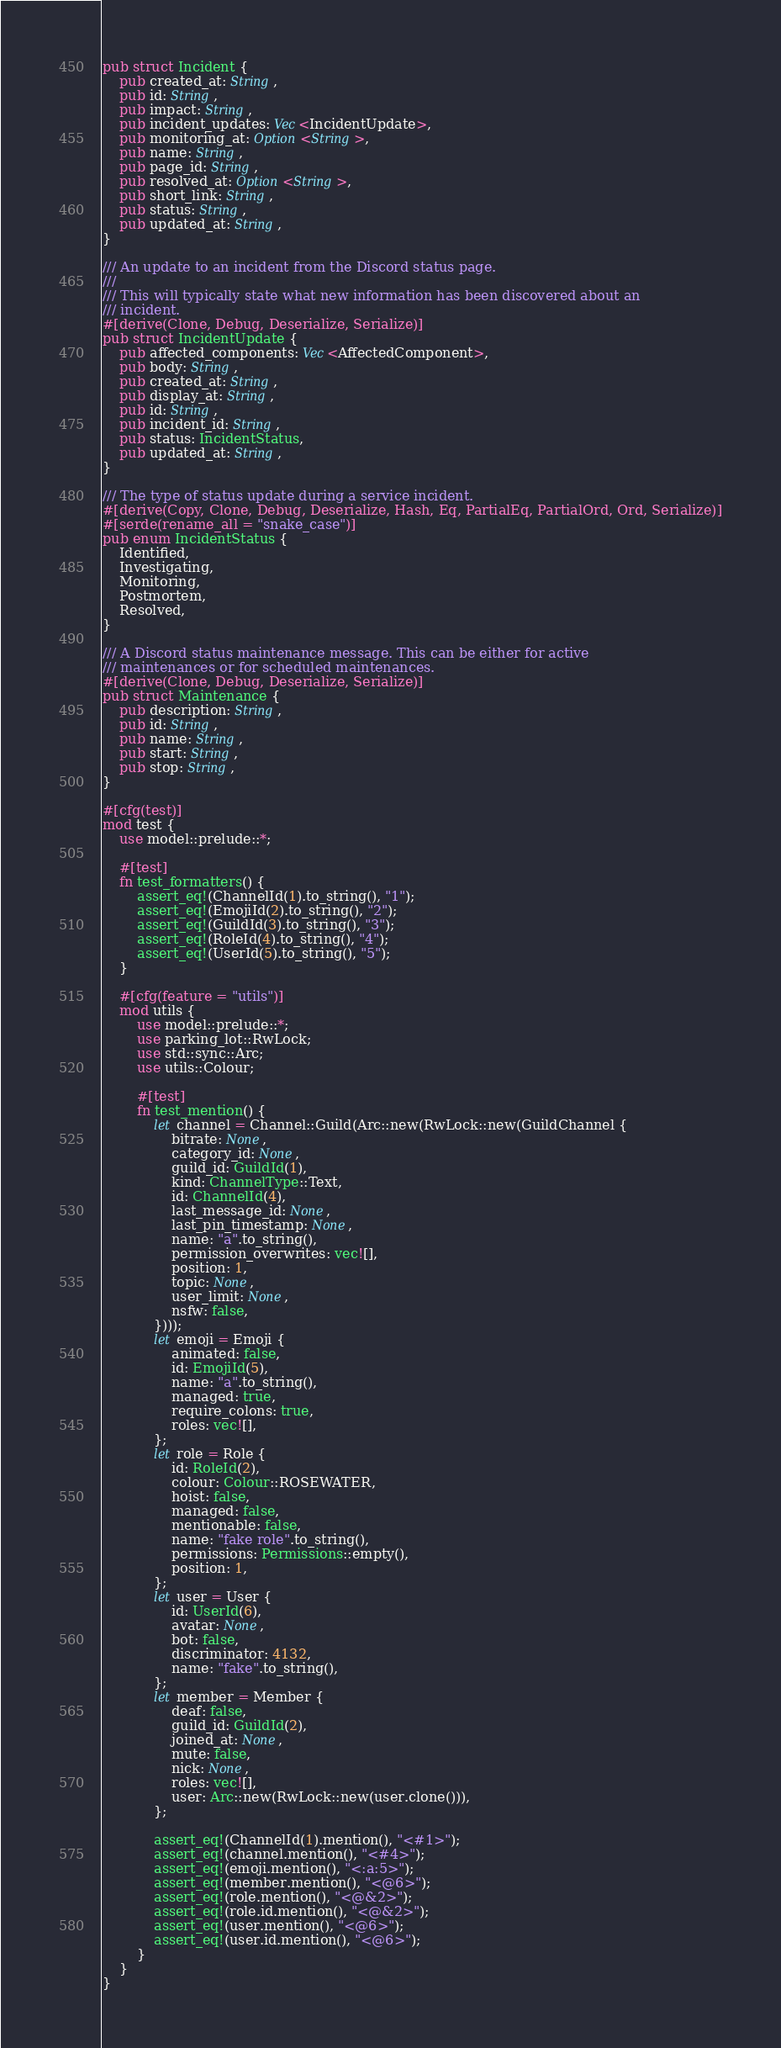Convert code to text. <code><loc_0><loc_0><loc_500><loc_500><_Rust_>pub struct Incident {
    pub created_at: String,
    pub id: String,
    pub impact: String,
    pub incident_updates: Vec<IncidentUpdate>,
    pub monitoring_at: Option<String>,
    pub name: String,
    pub page_id: String,
    pub resolved_at: Option<String>,
    pub short_link: String,
    pub status: String,
    pub updated_at: String,
}

/// An update to an incident from the Discord status page.
///
/// This will typically state what new information has been discovered about an
/// incident.
#[derive(Clone, Debug, Deserialize, Serialize)]
pub struct IncidentUpdate {
    pub affected_components: Vec<AffectedComponent>,
    pub body: String,
    pub created_at: String,
    pub display_at: String,
    pub id: String,
    pub incident_id: String,
    pub status: IncidentStatus,
    pub updated_at: String,
}

/// The type of status update during a service incident.
#[derive(Copy, Clone, Debug, Deserialize, Hash, Eq, PartialEq, PartialOrd, Ord, Serialize)]
#[serde(rename_all = "snake_case")]
pub enum IncidentStatus {
    Identified,
    Investigating,
    Monitoring,
    Postmortem,
    Resolved,
}

/// A Discord status maintenance message. This can be either for active
/// maintenances or for scheduled maintenances.
#[derive(Clone, Debug, Deserialize, Serialize)]
pub struct Maintenance {
    pub description: String,
    pub id: String,
    pub name: String,
    pub start: String,
    pub stop: String,
}

#[cfg(test)]
mod test {
    use model::prelude::*;

    #[test]
    fn test_formatters() {
        assert_eq!(ChannelId(1).to_string(), "1");
        assert_eq!(EmojiId(2).to_string(), "2");
        assert_eq!(GuildId(3).to_string(), "3");
        assert_eq!(RoleId(4).to_string(), "4");
        assert_eq!(UserId(5).to_string(), "5");
    }

    #[cfg(feature = "utils")]
    mod utils {
        use model::prelude::*;
        use parking_lot::RwLock;
        use std::sync::Arc;
        use utils::Colour;

        #[test]
        fn test_mention() {
            let channel = Channel::Guild(Arc::new(RwLock::new(GuildChannel {
                bitrate: None,
                category_id: None,
                guild_id: GuildId(1),
                kind: ChannelType::Text,
                id: ChannelId(4),
                last_message_id: None,
                last_pin_timestamp: None,
                name: "a".to_string(),
                permission_overwrites: vec![],
                position: 1,
                topic: None,
                user_limit: None,
                nsfw: false,
            })));
            let emoji = Emoji {
                animated: false,
                id: EmojiId(5),
                name: "a".to_string(),
                managed: true,
                require_colons: true,
                roles: vec![],
            };
            let role = Role {
                id: RoleId(2),
                colour: Colour::ROSEWATER,
                hoist: false,
                managed: false,
                mentionable: false,
                name: "fake role".to_string(),
                permissions: Permissions::empty(),
                position: 1,
            };
            let user = User {
                id: UserId(6),
                avatar: None,
                bot: false,
                discriminator: 4132,
                name: "fake".to_string(),
            };
            let member = Member {
                deaf: false,
                guild_id: GuildId(2),
                joined_at: None,
                mute: false,
                nick: None,
                roles: vec![],
                user: Arc::new(RwLock::new(user.clone())),
            };

            assert_eq!(ChannelId(1).mention(), "<#1>");
            assert_eq!(channel.mention(), "<#4>");
            assert_eq!(emoji.mention(), "<:a:5>");
            assert_eq!(member.mention(), "<@6>");
            assert_eq!(role.mention(), "<@&2>");
            assert_eq!(role.id.mention(), "<@&2>");
            assert_eq!(user.mention(), "<@6>");
            assert_eq!(user.id.mention(), "<@6>");
        }
    }
}
</code> 